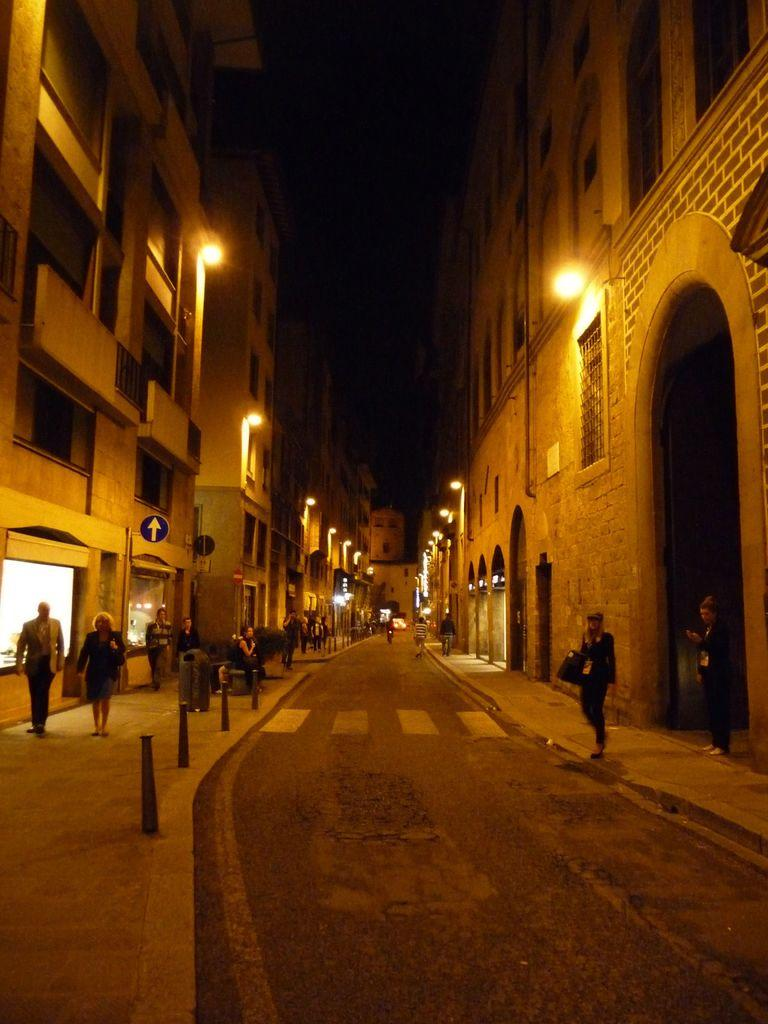What can be seen on the roads in the image? There are people on the roads in the image. What type of structures are visible in the image? There are buildings with windows in the image. What are the lights attached to on the buildings? The lights are attached to the buildings. What are the poles used for in the image? The poles are likely used for supporting lights or sign boards. What can be seen on the sign boards in the image? Sign boards are present in the image, but their content is not specified. How would you describe the lighting conditions in the image? The sky is dark in the image, which suggests it might be nighttime or overcast. What type of discussion is taking place among the people in the image? There is no indication of a discussion taking place among the people in the image. Are the people in the image sleeping? There is no indication that the people in the image are sleeping. 